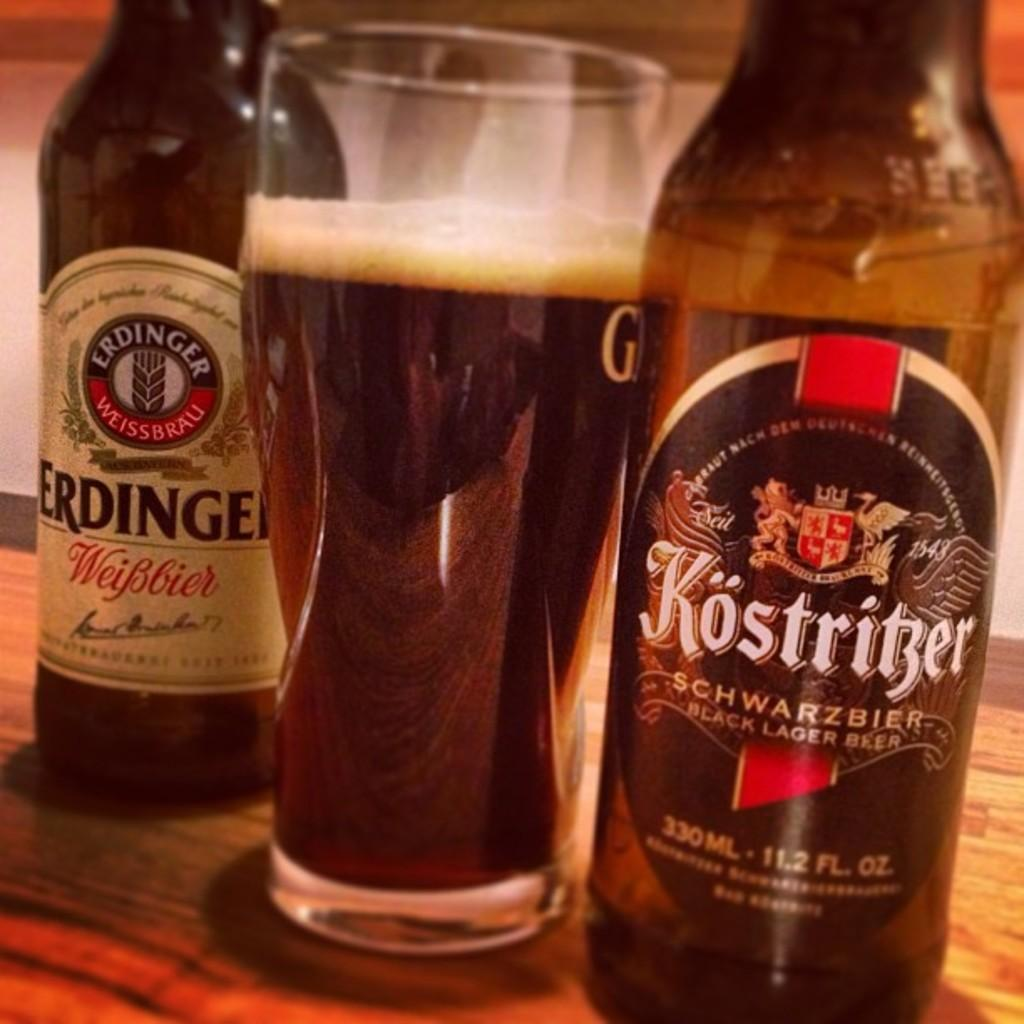Provide a one-sentence caption for the provided image. A bottle of Kostritzer lager sits next to a full glass of beer. 